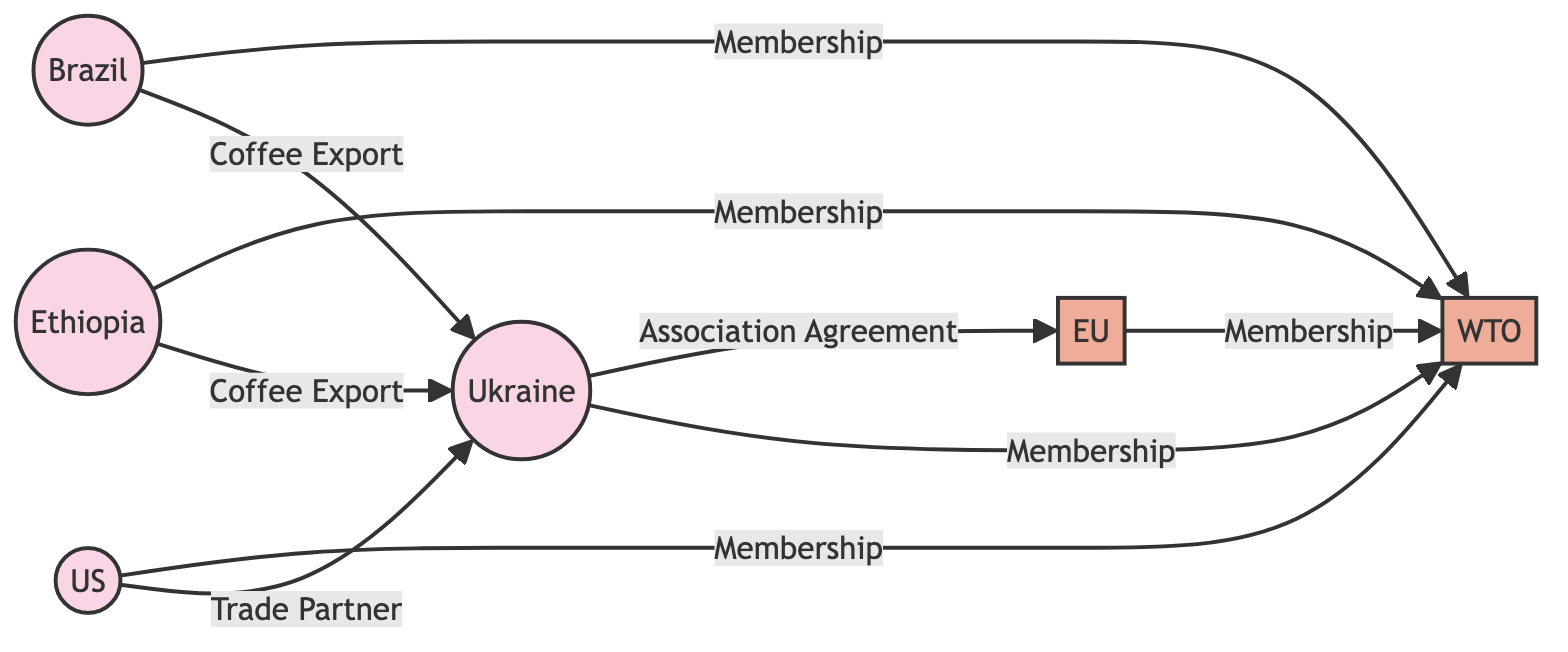What is the total number of countries in the diagram? There are five nodes identified as countries in the diagram: Ukraine, Brazil, Ethiopia, US. Counting these gives us the total number of countries, which equals four.
Answer: 4 What organization is Ukraine associated with? The diagram shows an edge labeled "Association Agreement" connecting Ukraine to the EU, indicating that Ukraine has an association with the EU.
Answer: EU Which countries export coffee to Ukraine? The diagram indicates that both Brazil and Ethiopia have edges labeled "Coffee Export" leading to Ukraine, meaning these two countries export coffee to Ukraine.
Answer: Brazil, Ethiopia How many organizations are members of the WTO? The diagram lists four entities that are connected by edges labeled "Membership" to the WTO, which are Brazil, Ethiopia, EU, and US. Counting these gives us the total number of organization members, which equals four.
Answer: 4 What is the relationship between the US and Ukraine? The diagram shows a direct edge between US and Ukraine labeled "Trade Partner," indicating the nature of their relationship.
Answer: Trade Partner Which country does not have a direct connection to the WTO? In the diagram, Ukraine has an edge to the WTO indicating its membership, while there is no edge connecting Brazil directly to the WTO because it explicitly states "Membership" to WTO, making them all connected. Therefore, every listed country is connected here.
Answer: None What description is associated with the EU? The diagram includes a node labeled EU with an attribute description saying "European Union." Thus, the description associated with the EU is clearly defined.
Answer: European Union Which country in the diagram is located in North America? The node labeled US is identified as a country in the diagram, specifically noted to be in the region of North America. Therefore, the country located in North America is US.
Answer: US What type of relationship does Brazil have with Ukraine? The diagram specifies a directed edge from Brazil to Ukraine with the label "Coffee Export," indicating the type of relationship that exists between them.
Answer: Coffee Export 